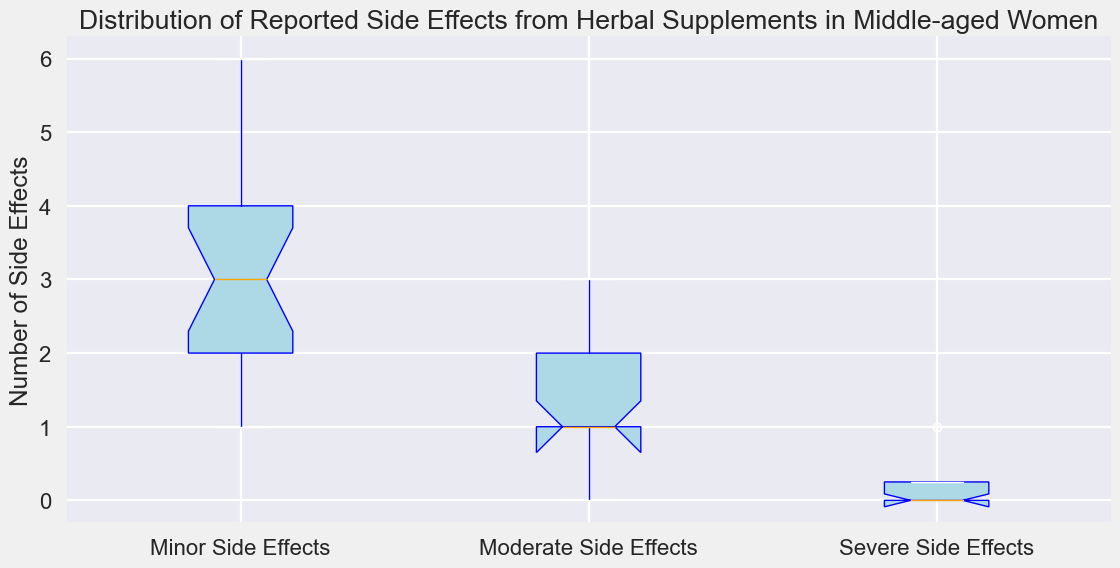Which category of side effects has the highest median value? The orange line in each box represents the median value. The box for "Minor Side Effects" has the highest median line compared to the boxes for "Moderate Side Effects" and "Severe Side Effects"
Answer: Minor Side Effects Between "Moderate Side Effects" and "Severe Side Effects", which has a wider distribution of reported side effects? The length of the boxes and the whiskers indicate distribution. The box and whiskers for "Moderate Side Effects" are longer compared to those for "Severe Side Effects," indicating a wider distribution
Answer: Moderate Side Effects By comparing the heights of the boxes, which side effect category shows the least variability? The variability is represented by the height of the boxes. The "Severe Side Effects" box is the shortest, indicating the least variability
Answer: Severe Side Effects What is the range of minor side effects reported? The range is found by subtracting the minimum value from the maximum value represented by the whiskers. For "Minor Side Effects," the minimum is 1, and the maximum is 6, so the range is 6 - 1 = 5
Answer: 5 Are there any side effects where the median value is zero? The orange median lines within the boxes indicate the median values. None of the categories have a median line at zero
Answer: No Which category of side effects has outliers represented by red markers? The red markers indicate outliers. In this plot, only "Moderate Side Effects" has red markers indicating outliers
Answer: Moderate Side Effects How many data points fall below the lower whisker of the "Moderate Side Effects" category? Red markers below the lower whisker of "Moderate Side Effects" represent outlying data points. There is one red marker indicating one outlier below the lower whisker
Answer: 1 What is the interquartile range (IQR) of "Severe Side Effects"? IQR is the difference between the third quartile (Q3) and first quartile (Q1). For "Severe Side Effects," Q3 is 1 and Q1 is 0. So, the IQR is 1 - 0 = 1
Answer: 1 